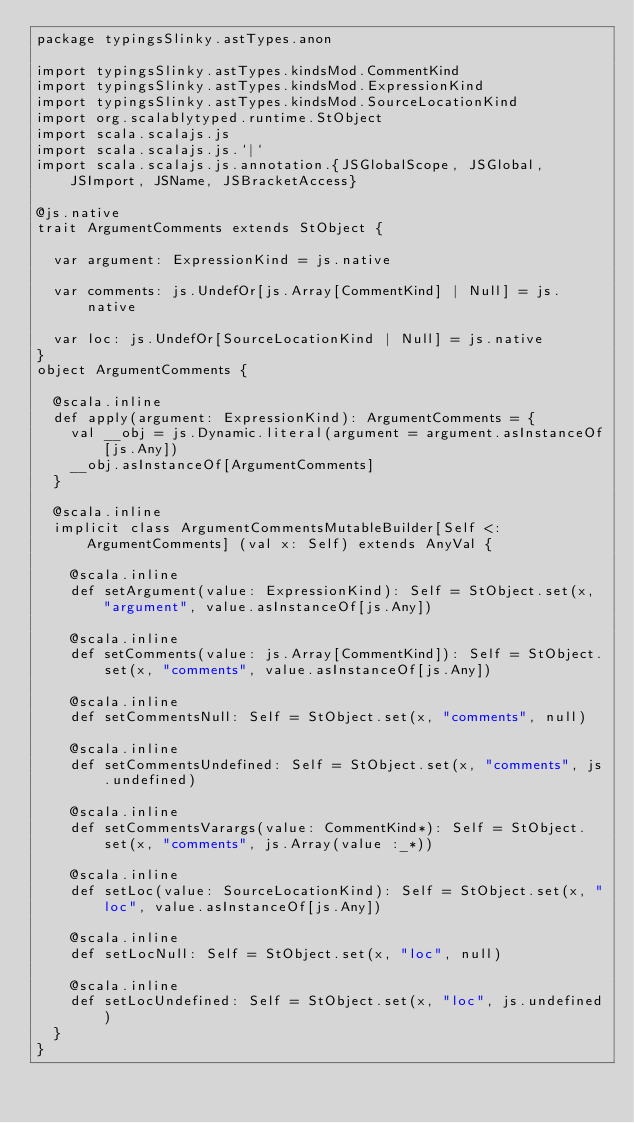Convert code to text. <code><loc_0><loc_0><loc_500><loc_500><_Scala_>package typingsSlinky.astTypes.anon

import typingsSlinky.astTypes.kindsMod.CommentKind
import typingsSlinky.astTypes.kindsMod.ExpressionKind
import typingsSlinky.astTypes.kindsMod.SourceLocationKind
import org.scalablytyped.runtime.StObject
import scala.scalajs.js
import scala.scalajs.js.`|`
import scala.scalajs.js.annotation.{JSGlobalScope, JSGlobal, JSImport, JSName, JSBracketAccess}

@js.native
trait ArgumentComments extends StObject {
  
  var argument: ExpressionKind = js.native
  
  var comments: js.UndefOr[js.Array[CommentKind] | Null] = js.native
  
  var loc: js.UndefOr[SourceLocationKind | Null] = js.native
}
object ArgumentComments {
  
  @scala.inline
  def apply(argument: ExpressionKind): ArgumentComments = {
    val __obj = js.Dynamic.literal(argument = argument.asInstanceOf[js.Any])
    __obj.asInstanceOf[ArgumentComments]
  }
  
  @scala.inline
  implicit class ArgumentCommentsMutableBuilder[Self <: ArgumentComments] (val x: Self) extends AnyVal {
    
    @scala.inline
    def setArgument(value: ExpressionKind): Self = StObject.set(x, "argument", value.asInstanceOf[js.Any])
    
    @scala.inline
    def setComments(value: js.Array[CommentKind]): Self = StObject.set(x, "comments", value.asInstanceOf[js.Any])
    
    @scala.inline
    def setCommentsNull: Self = StObject.set(x, "comments", null)
    
    @scala.inline
    def setCommentsUndefined: Self = StObject.set(x, "comments", js.undefined)
    
    @scala.inline
    def setCommentsVarargs(value: CommentKind*): Self = StObject.set(x, "comments", js.Array(value :_*))
    
    @scala.inline
    def setLoc(value: SourceLocationKind): Self = StObject.set(x, "loc", value.asInstanceOf[js.Any])
    
    @scala.inline
    def setLocNull: Self = StObject.set(x, "loc", null)
    
    @scala.inline
    def setLocUndefined: Self = StObject.set(x, "loc", js.undefined)
  }
}
</code> 